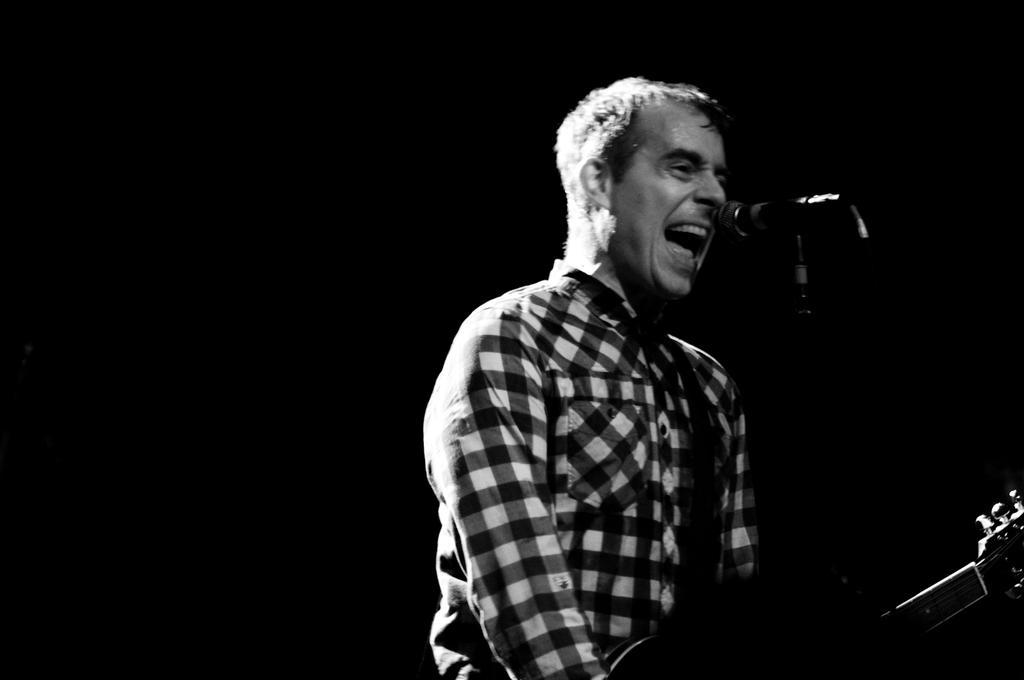What is the person in the image doing? The person is holding a guitar and appears to be singing, as their mouth is open. What object is the person holding in the image? The person is holding a guitar. What is in front of the person that might be used for amplifying their voice? There is a microphone stand in front of the person. How many accounts does the twig have in the image? There is no twig present in the image, so it is not possible to determine the number of accounts associated with it. 